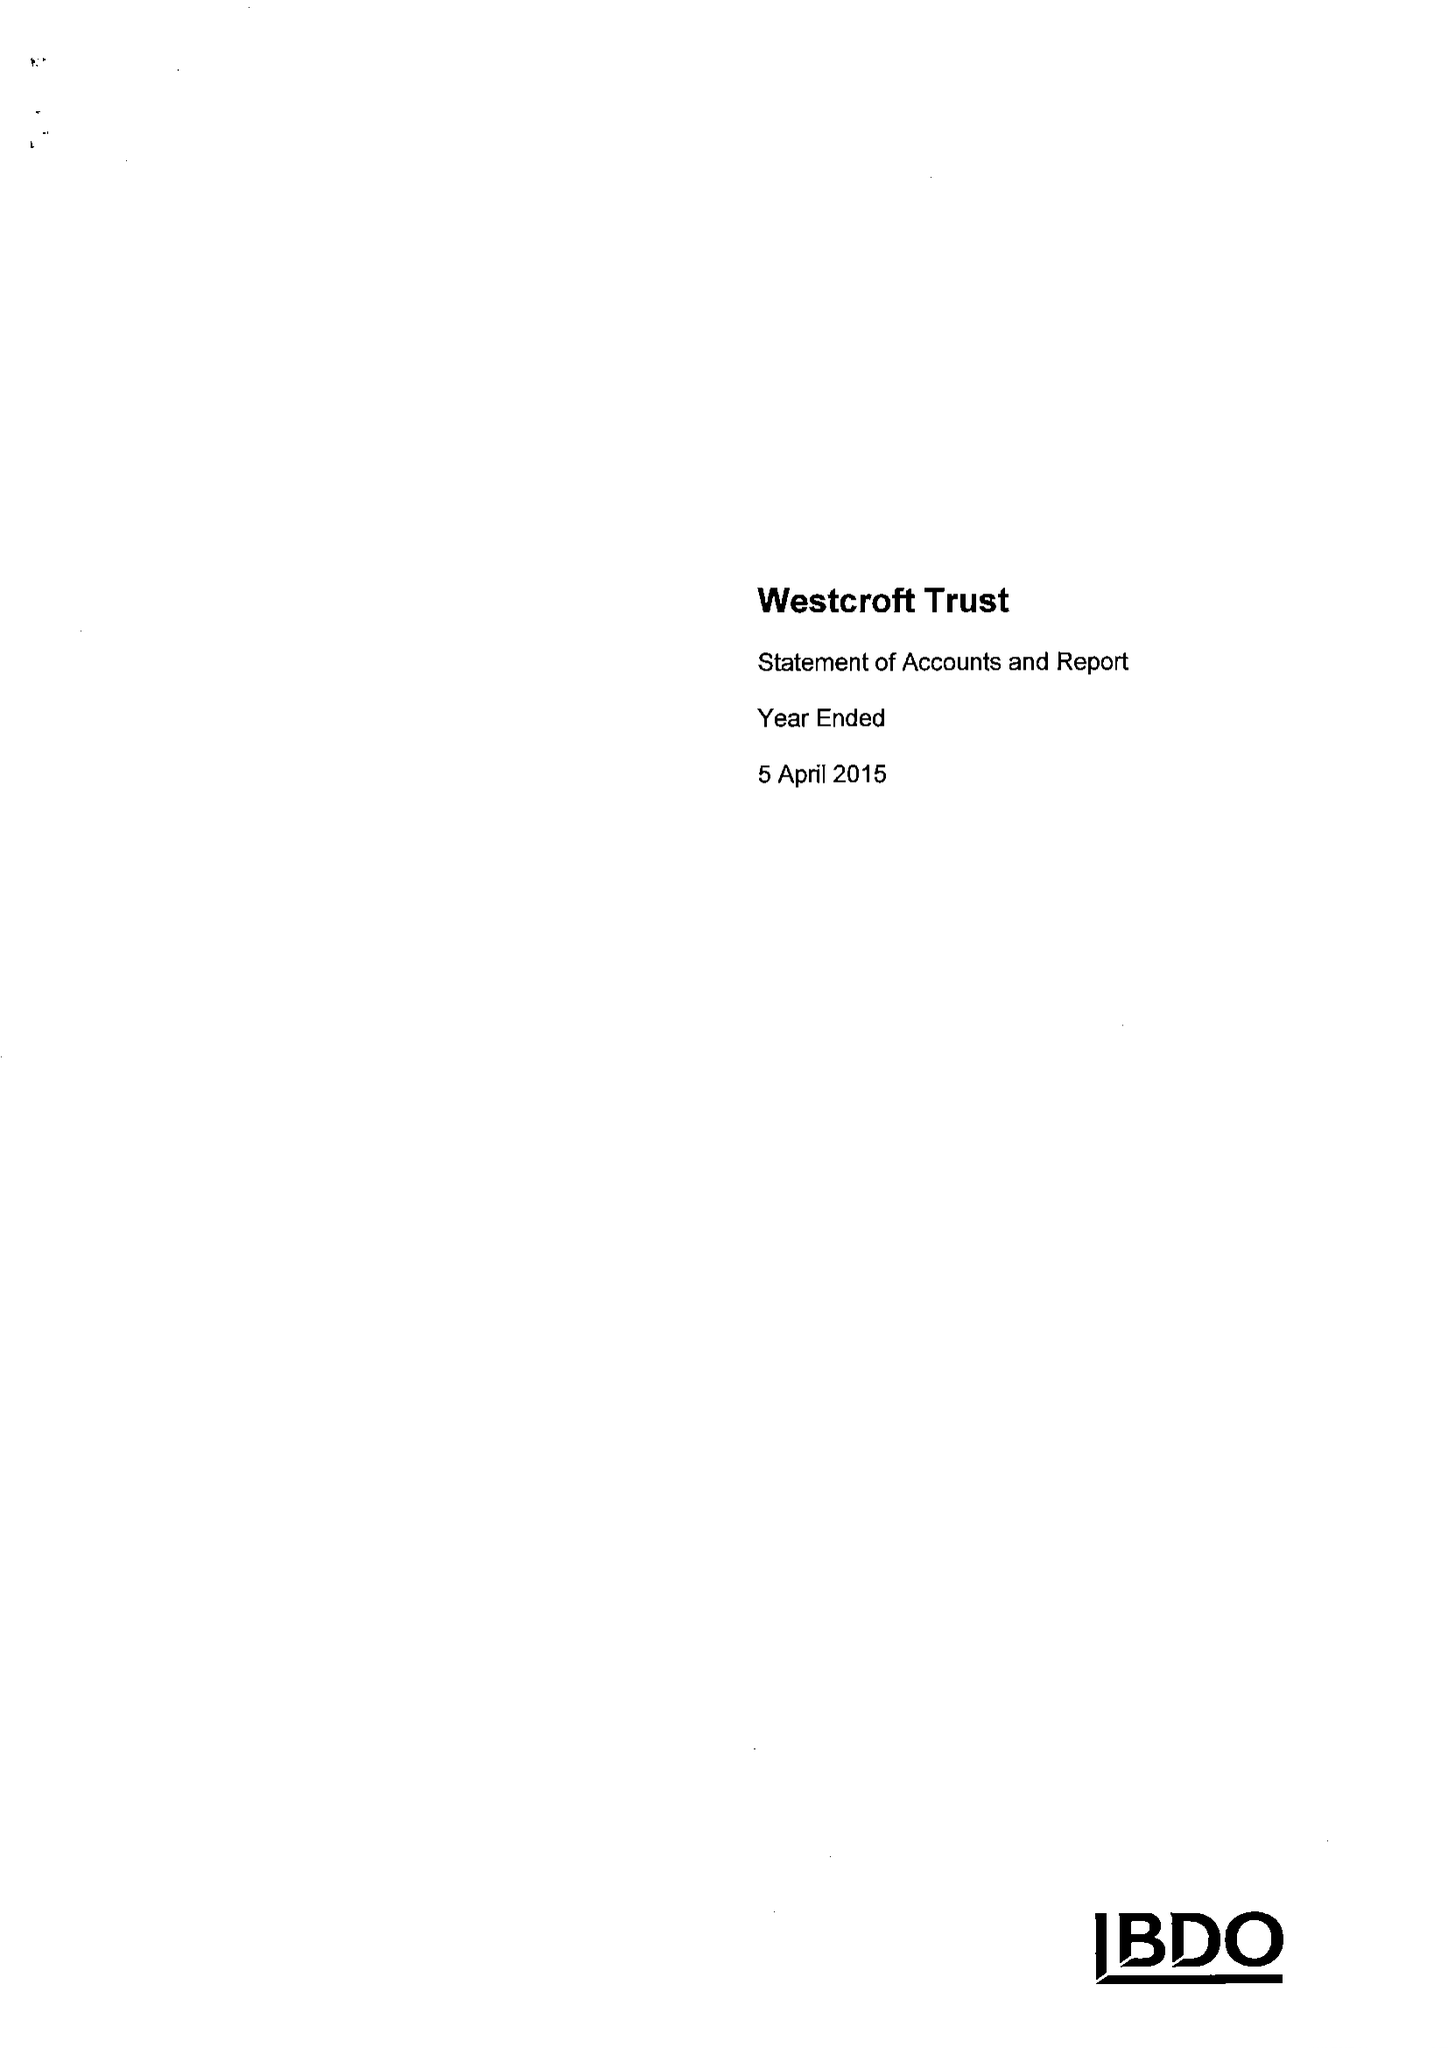What is the value for the address__postcode?
Answer the question using a single word or phrase. SY11 1SJ 